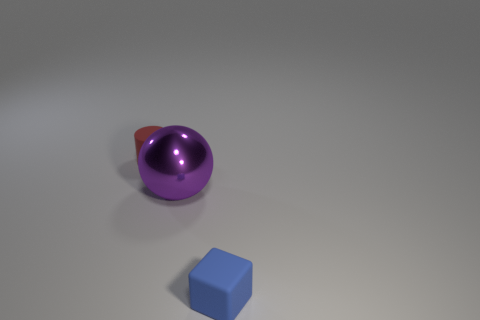Add 2 small cubes. How many objects exist? 5 Subtract all balls. How many objects are left? 2 Add 1 tiny blue rubber objects. How many tiny blue rubber objects exist? 2 Subtract 0 purple cylinders. How many objects are left? 3 Subtract all rubber cubes. Subtract all spheres. How many objects are left? 1 Add 2 red rubber things. How many red rubber things are left? 3 